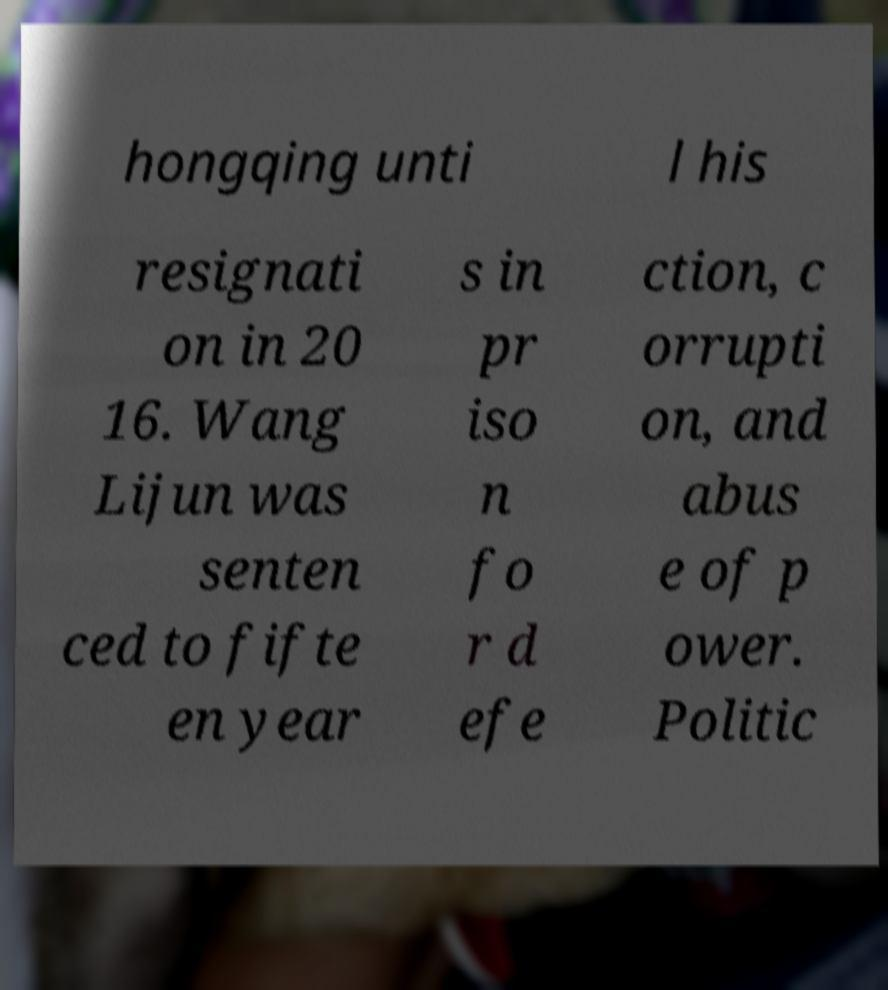Could you assist in decoding the text presented in this image and type it out clearly? hongqing unti l his resignati on in 20 16. Wang Lijun was senten ced to fifte en year s in pr iso n fo r d efe ction, c orrupti on, and abus e of p ower. Politic 